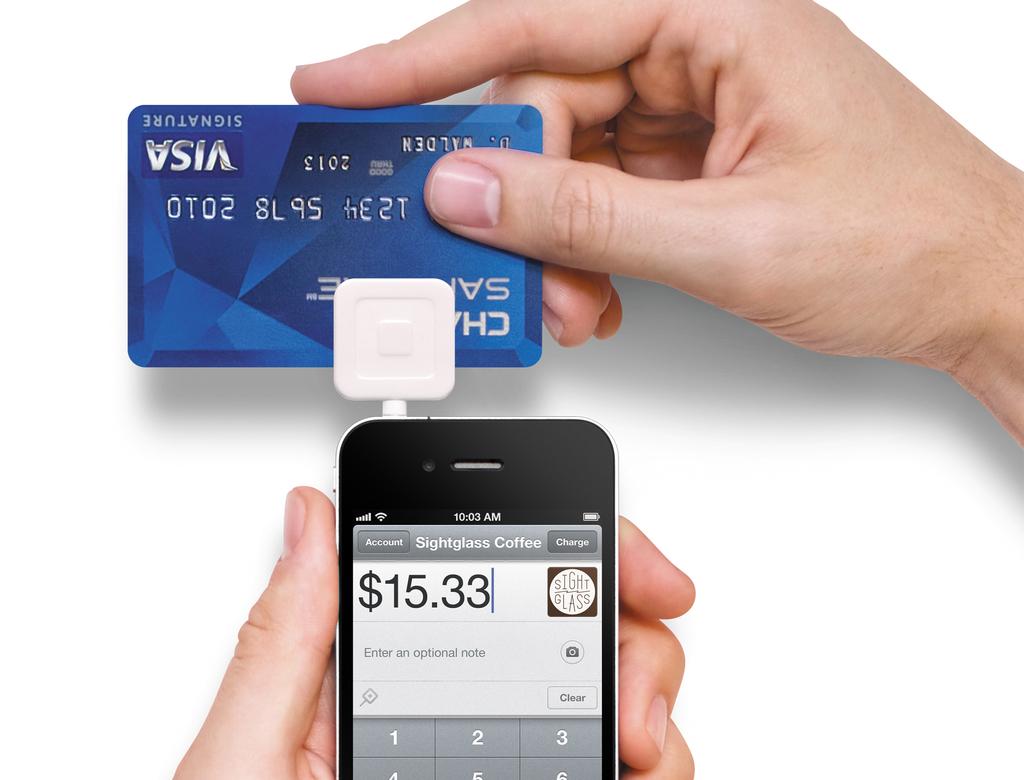What is the dollar value on the phone?
Ensure brevity in your answer.  15.33. Who issued the credit card?
Offer a very short reply. Chase. 